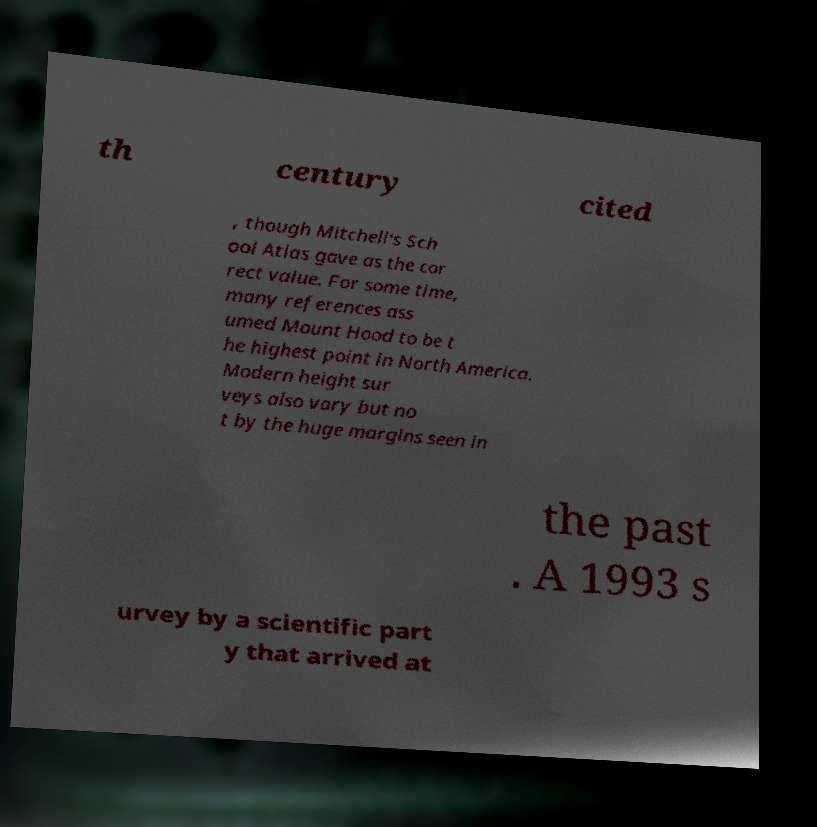Could you assist in decoding the text presented in this image and type it out clearly? th century cited , though Mitchell's Sch ool Atlas gave as the cor rect value. For some time, many references ass umed Mount Hood to be t he highest point in North America. Modern height sur veys also vary but no t by the huge margins seen in the past . A 1993 s urvey by a scientific part y that arrived at 